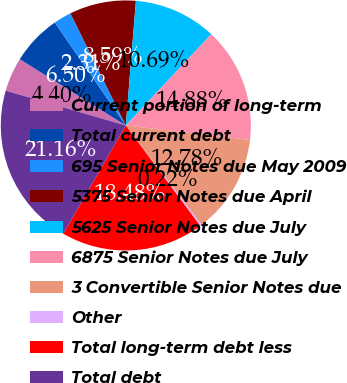Convert chart. <chart><loc_0><loc_0><loc_500><loc_500><pie_chart><fcel>Current portion of long-term<fcel>Total current debt<fcel>695 Senior Notes due May 2009<fcel>5375 Senior Notes due April<fcel>5625 Senior Notes due July<fcel>6875 Senior Notes due July<fcel>3 Convertible Senior Notes due<fcel>Other<fcel>Total long-term debt less<fcel>Total debt<nl><fcel>4.4%<fcel>6.5%<fcel>2.31%<fcel>8.59%<fcel>10.69%<fcel>14.88%<fcel>12.78%<fcel>0.22%<fcel>18.48%<fcel>21.16%<nl></chart> 